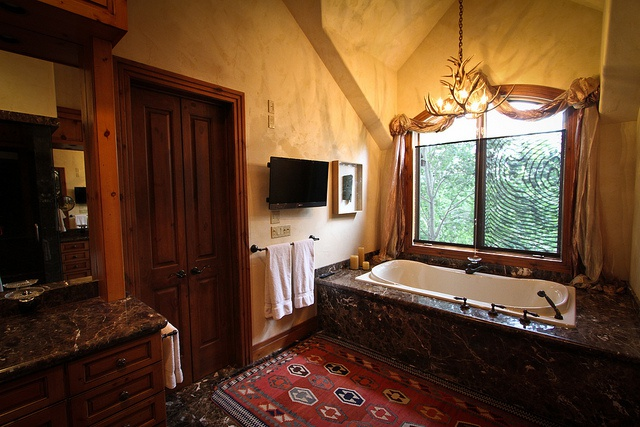Describe the objects in this image and their specific colors. I can see a tv in black, maroon, and lightgray tones in this image. 